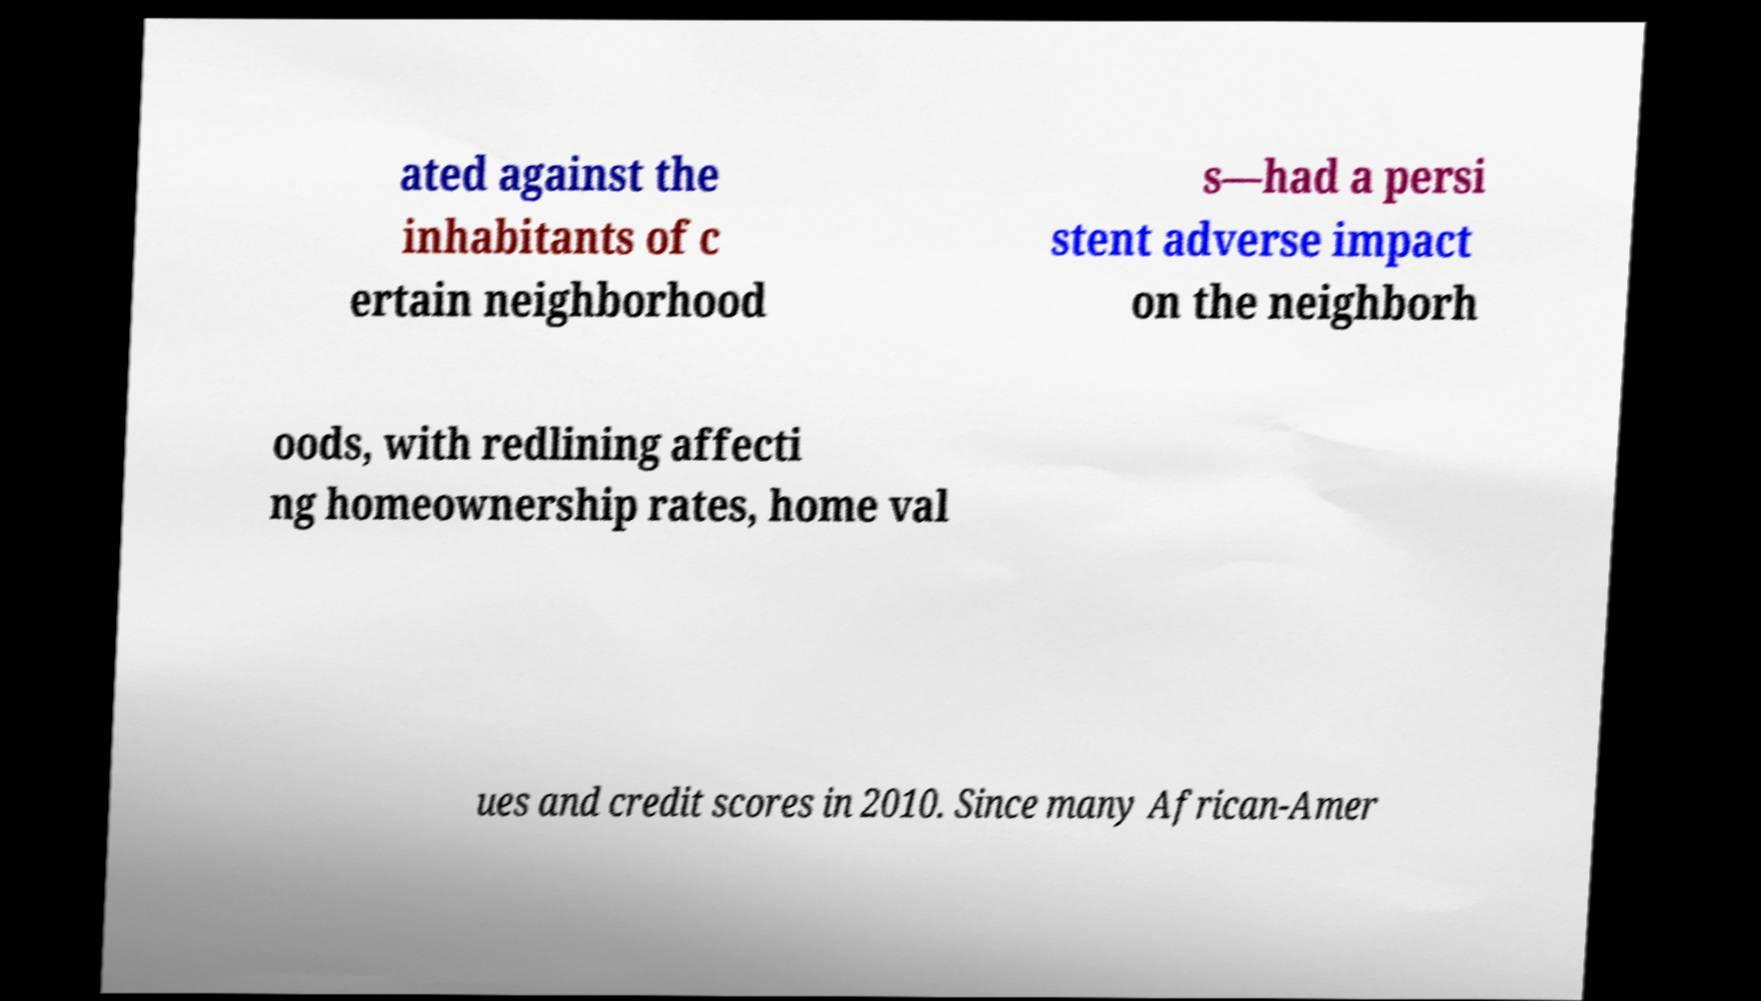There's text embedded in this image that I need extracted. Can you transcribe it verbatim? ated against the inhabitants of c ertain neighborhood s—had a persi stent adverse impact on the neighborh oods, with redlining affecti ng homeownership rates, home val ues and credit scores in 2010. Since many African-Amer 